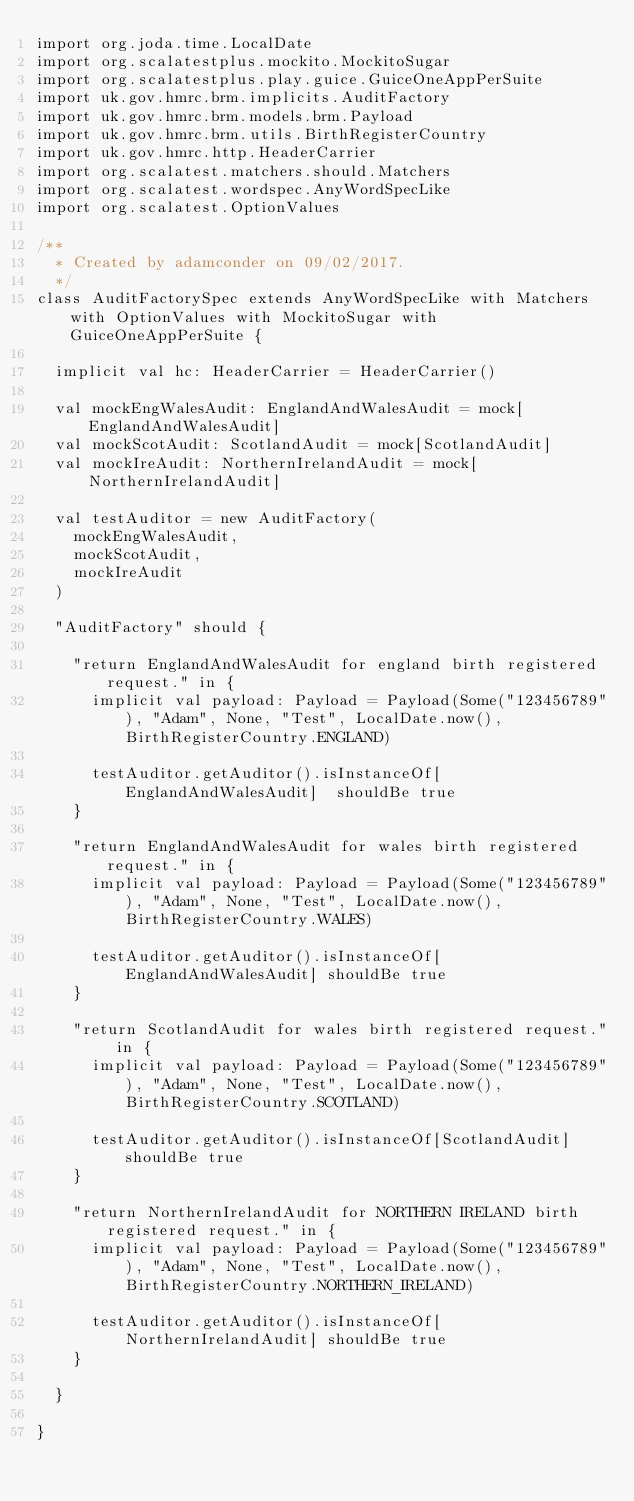<code> <loc_0><loc_0><loc_500><loc_500><_Scala_>import org.joda.time.LocalDate
import org.scalatestplus.mockito.MockitoSugar
import org.scalatestplus.play.guice.GuiceOneAppPerSuite
import uk.gov.hmrc.brm.implicits.AuditFactory
import uk.gov.hmrc.brm.models.brm.Payload
import uk.gov.hmrc.brm.utils.BirthRegisterCountry
import uk.gov.hmrc.http.HeaderCarrier
import org.scalatest.matchers.should.Matchers
import org.scalatest.wordspec.AnyWordSpecLike
import org.scalatest.OptionValues

/**
  * Created by adamconder on 09/02/2017.
  */
class AuditFactorySpec extends AnyWordSpecLike with Matchers with OptionValues with MockitoSugar with GuiceOneAppPerSuite {

  implicit val hc: HeaderCarrier = HeaderCarrier()

  val mockEngWalesAudit: EnglandAndWalesAudit = mock[EnglandAndWalesAudit]
  val mockScotAudit: ScotlandAudit = mock[ScotlandAudit]
  val mockIreAudit: NorthernIrelandAudit = mock[NorthernIrelandAudit]

  val testAuditor = new AuditFactory(
    mockEngWalesAudit,
    mockScotAudit,
    mockIreAudit
  )

  "AuditFactory" should {

    "return EnglandAndWalesAudit for england birth registered request." in {
      implicit val payload: Payload = Payload(Some("123456789"), "Adam", None, "Test", LocalDate.now(), BirthRegisterCountry.ENGLAND)

      testAuditor.getAuditor().isInstanceOf[EnglandAndWalesAudit]  shouldBe true
    }

    "return EnglandAndWalesAudit for wales birth registered request." in {
      implicit val payload: Payload = Payload(Some("123456789"), "Adam", None, "Test", LocalDate.now(), BirthRegisterCountry.WALES)

      testAuditor.getAuditor().isInstanceOf[EnglandAndWalesAudit] shouldBe true
    }

    "return ScotlandAudit for wales birth registered request." in {
      implicit val payload: Payload = Payload(Some("123456789"), "Adam", None, "Test", LocalDate.now(), BirthRegisterCountry.SCOTLAND)

      testAuditor.getAuditor().isInstanceOf[ScotlandAudit] shouldBe true
    }

    "return NorthernIrelandAudit for NORTHERN IRELAND birth registered request." in {
      implicit val payload: Payload = Payload(Some("123456789"), "Adam", None, "Test", LocalDate.now(), BirthRegisterCountry.NORTHERN_IRELAND)

      testAuditor.getAuditor().isInstanceOf[NorthernIrelandAudit] shouldBe true
    }

  }

}
</code> 